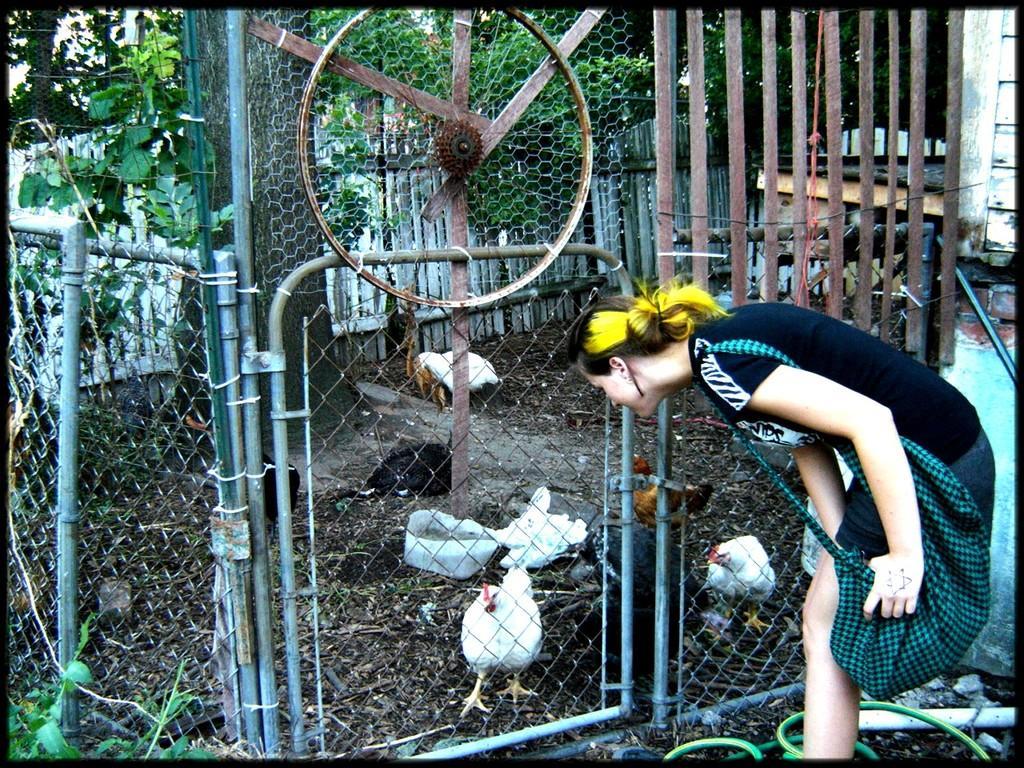In one or two sentences, can you explain what this image depicts? In this image we can see a grille. Behind the grille hens are present and tree is there and one wooden fence is available. Right side of the image one lady is standing by holding green color bag, she is wearing black t-shirt with shorts. 